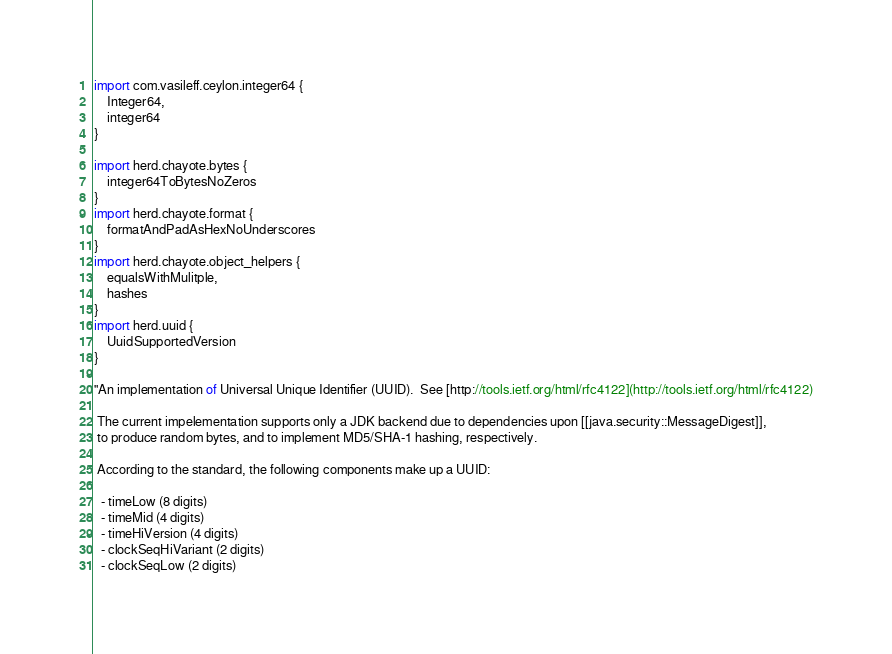Convert code to text. <code><loc_0><loc_0><loc_500><loc_500><_Ceylon_>import com.vasileff.ceylon.integer64 {
    Integer64,
    integer64
}

import herd.chayote.bytes {
    integer64ToBytesNoZeros
}
import herd.chayote.format {
    formatAndPadAsHexNoUnderscores
}
import herd.chayote.object_helpers {
    equalsWithMulitple,
    hashes
}
import herd.uuid {
    UuidSupportedVersion
}

"An implementation of Universal Unique Identifier (UUID).  See [http://tools.ietf.org/html/rfc4122](http://tools.ietf.org/html/rfc4122)

 The current impelementation supports only a JDK backend due to dependencies upon [[java.security::MessageDigest]],
 to produce random bytes, and to implement MD5/SHA-1 hashing, respectively.

 According to the standard, the following components make up a UUID:

  - timeLow (8 digits)
  - timeMid (4 digits)
  - timeHiVersion (4 digits)
  - clockSeqHiVariant (2 digits)
  - clockSeqLow (2 digits)</code> 